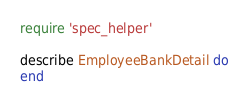<code> <loc_0><loc_0><loc_500><loc_500><_Ruby_>require 'spec_helper'

describe EmployeeBankDetail do
end
</code> 